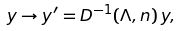Convert formula to latex. <formula><loc_0><loc_0><loc_500><loc_500>y \rightarrow y ^ { \prime } = { D ^ { - 1 } ( \Lambda , n ) } \, y ,</formula> 